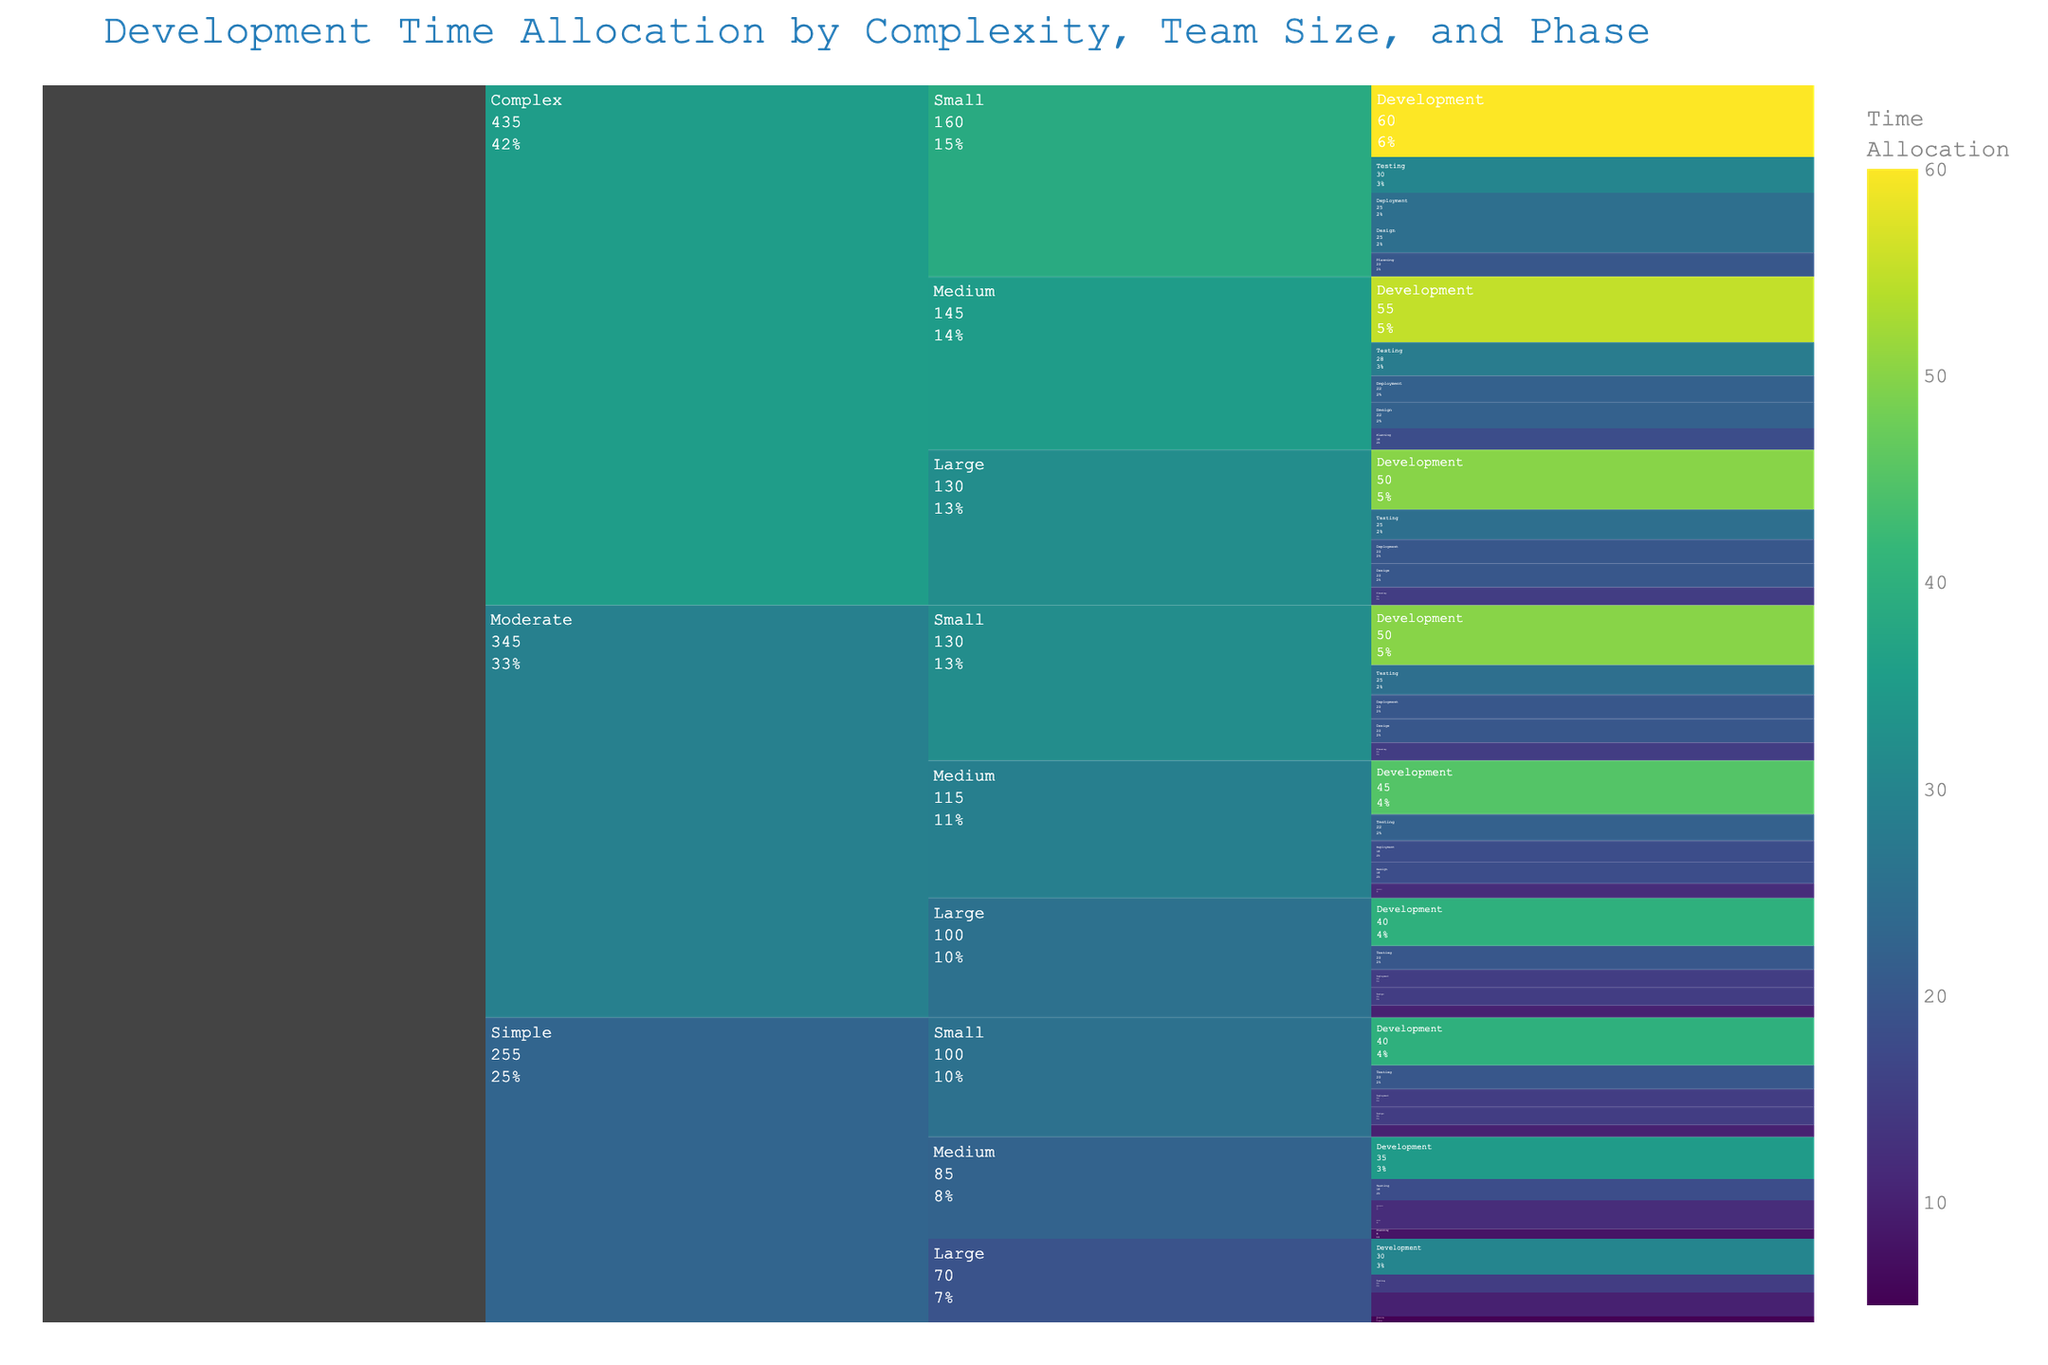What's the title of the figure? The title is displayed prominently at the top of the figure. It indicates the chart's content and context.
Answer: Development Time Allocation by Complexity, Team Size, and Phase Which complexity level has the highest total time allocation for the Planning phase? First, locate the Planning phase across all complexities. Then sum the time allocations for the Planning phase within each complexity. Complex level is compared based on higher total.
Answer: Complex What is the time allocation for the Design phase for a Medium-sized team working on a Moderate complexity app? Navigate through the chart to find the path: Moderate > Medium > Design. Then, check the time allocation value displayed.
Answer: 18 Compare the time allocation for the Testing phase between Simple complexity with a Small team and Complex complexity with a Large team. Which is higher? Locate the Testing phase for both Simple/Small and Complex/Large categories. Compare the two values listed.
Answer: Complex complexity with a Large team For a Complex app with a Small team, what is the combined time allocation for Development and Testing phases? Locate the Development and Testing phases under the Complex/Small path. Add the time allocations for these two phases together.
Answer: 90 (60 + 30) Which team size has the least time allocation for Deployment across all complexities? Locate the Deployment phase for each complexity and identify the time allocations for Small, Medium, and Large team sizes. Sum the allocations for each size and determine the smallest total.
Answer: Large team How does the time allocation for Planning compare between Simple and Moderate apps with a Small team? Locate the Planning phase for Simple/Small and Moderate/Small. Compare their time allocation values directly.
Answer: Moderate apps have higher time allocation What's the difference in time allocation between the Design phase for a Complex app with a Medium team and a Simple app with a Large team? Find the Design phase values for Complex/Medium and Simple/Large. Subtract the latter from the former.
Answer: 12 (22 - 10) What percentage of the total allocated time for a Simple app with a Small team is devoted to Development? Find the time allocations for all phases of Simple/Small. Sum them up and then calculate the percentage that Development's time allocation represents.
Answer: 40% Which phase has the most consistent allocation across different complexities within a Medium-sized team? Check each phase under Medium-sized team across all complexities. Determine which phase has the smallest variance in time allocation values.
Answer: Deployment 